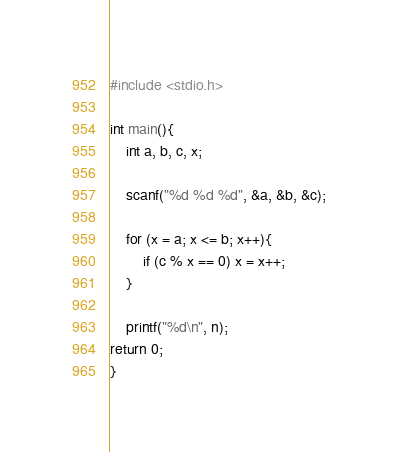<code> <loc_0><loc_0><loc_500><loc_500><_C_>#include <stdio.h>

int main(){
	int a, b, c, x;

	scanf("%d %d %d", &a, &b, &c);

	for (x = a; x <= b; x++){
		if (c % x == 0) x = x++;
	}

	printf("%d\n", n);
return 0;
}</code> 